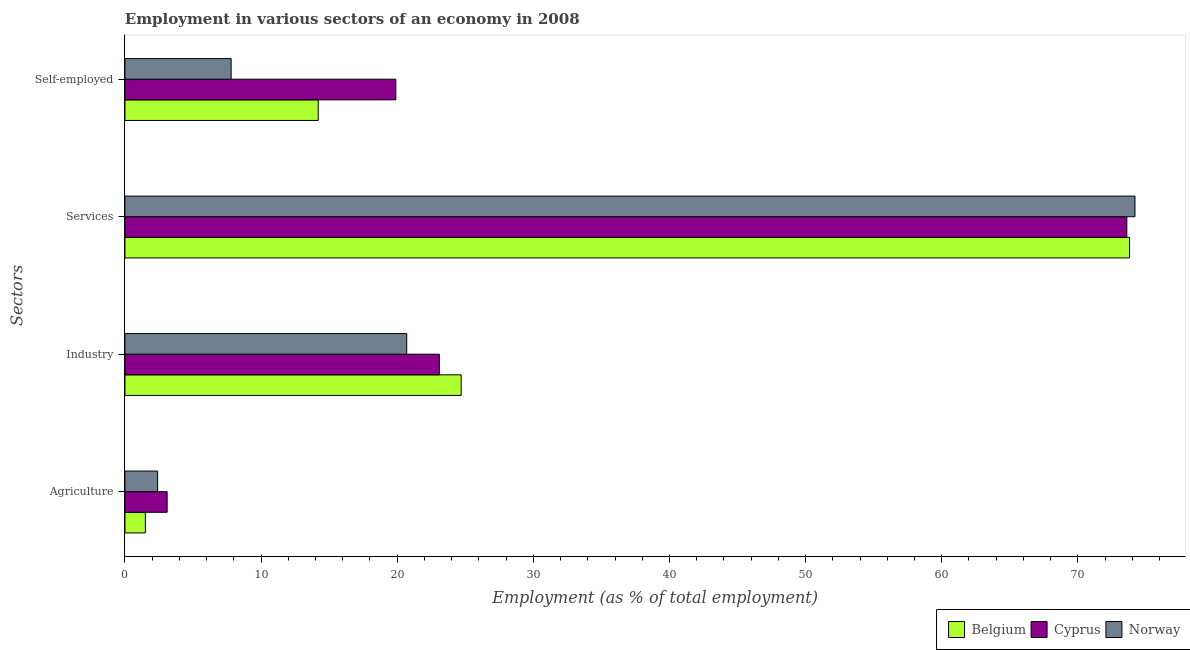How many different coloured bars are there?
Make the answer very short. 3. How many bars are there on the 1st tick from the top?
Give a very brief answer. 3. What is the label of the 3rd group of bars from the top?
Keep it short and to the point. Industry. What is the percentage of workers in agriculture in Norway?
Offer a terse response. 2.4. Across all countries, what is the maximum percentage of workers in services?
Offer a terse response. 74.2. Across all countries, what is the minimum percentage of workers in services?
Ensure brevity in your answer.  73.6. In which country was the percentage of self employed workers maximum?
Provide a succinct answer. Cyprus. In which country was the percentage of workers in services minimum?
Your response must be concise. Cyprus. What is the total percentage of workers in services in the graph?
Make the answer very short. 221.6. What is the difference between the percentage of workers in services in Belgium and that in Cyprus?
Ensure brevity in your answer.  0.2. What is the difference between the percentage of self employed workers in Cyprus and the percentage of workers in services in Belgium?
Offer a terse response. -53.9. What is the average percentage of workers in services per country?
Provide a succinct answer. 73.87. What is the difference between the percentage of self employed workers and percentage of workers in services in Belgium?
Your answer should be very brief. -59.6. What is the ratio of the percentage of workers in services in Cyprus to that in Norway?
Offer a terse response. 0.99. Is the percentage of self employed workers in Cyprus less than that in Belgium?
Your response must be concise. No. What is the difference between the highest and the second highest percentage of workers in industry?
Your response must be concise. 1.6. What is the difference between the highest and the lowest percentage of workers in agriculture?
Your response must be concise. 1.6. In how many countries, is the percentage of workers in industry greater than the average percentage of workers in industry taken over all countries?
Offer a very short reply. 2. Is it the case that in every country, the sum of the percentage of workers in industry and percentage of self employed workers is greater than the sum of percentage of workers in services and percentage of workers in agriculture?
Provide a short and direct response. No. What does the 2nd bar from the top in Agriculture represents?
Ensure brevity in your answer.  Cyprus. Is it the case that in every country, the sum of the percentage of workers in agriculture and percentage of workers in industry is greater than the percentage of workers in services?
Provide a short and direct response. No. Are all the bars in the graph horizontal?
Make the answer very short. Yes. How many countries are there in the graph?
Give a very brief answer. 3. What is the difference between two consecutive major ticks on the X-axis?
Give a very brief answer. 10. Does the graph contain any zero values?
Your response must be concise. No. Does the graph contain grids?
Your response must be concise. No. Where does the legend appear in the graph?
Your answer should be compact. Bottom right. How many legend labels are there?
Make the answer very short. 3. What is the title of the graph?
Offer a terse response. Employment in various sectors of an economy in 2008. What is the label or title of the X-axis?
Ensure brevity in your answer.  Employment (as % of total employment). What is the label or title of the Y-axis?
Make the answer very short. Sectors. What is the Employment (as % of total employment) in Cyprus in Agriculture?
Offer a terse response. 3.1. What is the Employment (as % of total employment) in Norway in Agriculture?
Offer a very short reply. 2.4. What is the Employment (as % of total employment) in Belgium in Industry?
Provide a succinct answer. 24.7. What is the Employment (as % of total employment) of Cyprus in Industry?
Your answer should be compact. 23.1. What is the Employment (as % of total employment) of Norway in Industry?
Offer a terse response. 20.7. What is the Employment (as % of total employment) of Belgium in Services?
Offer a very short reply. 73.8. What is the Employment (as % of total employment) of Cyprus in Services?
Offer a terse response. 73.6. What is the Employment (as % of total employment) in Norway in Services?
Provide a succinct answer. 74.2. What is the Employment (as % of total employment) in Belgium in Self-employed?
Ensure brevity in your answer.  14.2. What is the Employment (as % of total employment) of Cyprus in Self-employed?
Provide a succinct answer. 19.9. What is the Employment (as % of total employment) of Norway in Self-employed?
Make the answer very short. 7.8. Across all Sectors, what is the maximum Employment (as % of total employment) of Belgium?
Provide a short and direct response. 73.8. Across all Sectors, what is the maximum Employment (as % of total employment) in Cyprus?
Keep it short and to the point. 73.6. Across all Sectors, what is the maximum Employment (as % of total employment) in Norway?
Your answer should be compact. 74.2. Across all Sectors, what is the minimum Employment (as % of total employment) of Belgium?
Give a very brief answer. 1.5. Across all Sectors, what is the minimum Employment (as % of total employment) of Cyprus?
Provide a short and direct response. 3.1. Across all Sectors, what is the minimum Employment (as % of total employment) of Norway?
Give a very brief answer. 2.4. What is the total Employment (as % of total employment) in Belgium in the graph?
Your answer should be very brief. 114.2. What is the total Employment (as % of total employment) in Cyprus in the graph?
Give a very brief answer. 119.7. What is the total Employment (as % of total employment) of Norway in the graph?
Keep it short and to the point. 105.1. What is the difference between the Employment (as % of total employment) of Belgium in Agriculture and that in Industry?
Provide a short and direct response. -23.2. What is the difference between the Employment (as % of total employment) in Cyprus in Agriculture and that in Industry?
Provide a succinct answer. -20. What is the difference between the Employment (as % of total employment) in Norway in Agriculture and that in Industry?
Your answer should be compact. -18.3. What is the difference between the Employment (as % of total employment) of Belgium in Agriculture and that in Services?
Keep it short and to the point. -72.3. What is the difference between the Employment (as % of total employment) in Cyprus in Agriculture and that in Services?
Your response must be concise. -70.5. What is the difference between the Employment (as % of total employment) of Norway in Agriculture and that in Services?
Give a very brief answer. -71.8. What is the difference between the Employment (as % of total employment) of Belgium in Agriculture and that in Self-employed?
Your answer should be compact. -12.7. What is the difference between the Employment (as % of total employment) in Cyprus in Agriculture and that in Self-employed?
Your answer should be compact. -16.8. What is the difference between the Employment (as % of total employment) in Norway in Agriculture and that in Self-employed?
Your answer should be compact. -5.4. What is the difference between the Employment (as % of total employment) in Belgium in Industry and that in Services?
Your answer should be compact. -49.1. What is the difference between the Employment (as % of total employment) in Cyprus in Industry and that in Services?
Provide a short and direct response. -50.5. What is the difference between the Employment (as % of total employment) of Norway in Industry and that in Services?
Your answer should be compact. -53.5. What is the difference between the Employment (as % of total employment) in Belgium in Industry and that in Self-employed?
Your answer should be very brief. 10.5. What is the difference between the Employment (as % of total employment) of Belgium in Services and that in Self-employed?
Ensure brevity in your answer.  59.6. What is the difference between the Employment (as % of total employment) of Cyprus in Services and that in Self-employed?
Your answer should be compact. 53.7. What is the difference between the Employment (as % of total employment) in Norway in Services and that in Self-employed?
Keep it short and to the point. 66.4. What is the difference between the Employment (as % of total employment) in Belgium in Agriculture and the Employment (as % of total employment) in Cyprus in Industry?
Offer a terse response. -21.6. What is the difference between the Employment (as % of total employment) in Belgium in Agriculture and the Employment (as % of total employment) in Norway in Industry?
Make the answer very short. -19.2. What is the difference between the Employment (as % of total employment) of Cyprus in Agriculture and the Employment (as % of total employment) of Norway in Industry?
Your answer should be very brief. -17.6. What is the difference between the Employment (as % of total employment) in Belgium in Agriculture and the Employment (as % of total employment) in Cyprus in Services?
Give a very brief answer. -72.1. What is the difference between the Employment (as % of total employment) in Belgium in Agriculture and the Employment (as % of total employment) in Norway in Services?
Give a very brief answer. -72.7. What is the difference between the Employment (as % of total employment) of Cyprus in Agriculture and the Employment (as % of total employment) of Norway in Services?
Ensure brevity in your answer.  -71.1. What is the difference between the Employment (as % of total employment) of Belgium in Agriculture and the Employment (as % of total employment) of Cyprus in Self-employed?
Ensure brevity in your answer.  -18.4. What is the difference between the Employment (as % of total employment) in Belgium in Agriculture and the Employment (as % of total employment) in Norway in Self-employed?
Your response must be concise. -6.3. What is the difference between the Employment (as % of total employment) of Cyprus in Agriculture and the Employment (as % of total employment) of Norway in Self-employed?
Keep it short and to the point. -4.7. What is the difference between the Employment (as % of total employment) in Belgium in Industry and the Employment (as % of total employment) in Cyprus in Services?
Provide a short and direct response. -48.9. What is the difference between the Employment (as % of total employment) of Belgium in Industry and the Employment (as % of total employment) of Norway in Services?
Your answer should be compact. -49.5. What is the difference between the Employment (as % of total employment) of Cyprus in Industry and the Employment (as % of total employment) of Norway in Services?
Keep it short and to the point. -51.1. What is the difference between the Employment (as % of total employment) of Belgium in Industry and the Employment (as % of total employment) of Cyprus in Self-employed?
Give a very brief answer. 4.8. What is the difference between the Employment (as % of total employment) in Cyprus in Industry and the Employment (as % of total employment) in Norway in Self-employed?
Your answer should be very brief. 15.3. What is the difference between the Employment (as % of total employment) in Belgium in Services and the Employment (as % of total employment) in Cyprus in Self-employed?
Offer a terse response. 53.9. What is the difference between the Employment (as % of total employment) in Belgium in Services and the Employment (as % of total employment) in Norway in Self-employed?
Provide a short and direct response. 66. What is the difference between the Employment (as % of total employment) in Cyprus in Services and the Employment (as % of total employment) in Norway in Self-employed?
Offer a very short reply. 65.8. What is the average Employment (as % of total employment) of Belgium per Sectors?
Provide a succinct answer. 28.55. What is the average Employment (as % of total employment) of Cyprus per Sectors?
Provide a succinct answer. 29.93. What is the average Employment (as % of total employment) in Norway per Sectors?
Provide a succinct answer. 26.27. What is the difference between the Employment (as % of total employment) of Belgium and Employment (as % of total employment) of Norway in Agriculture?
Ensure brevity in your answer.  -0.9. What is the difference between the Employment (as % of total employment) in Cyprus and Employment (as % of total employment) in Norway in Agriculture?
Give a very brief answer. 0.7. What is the difference between the Employment (as % of total employment) of Belgium and Employment (as % of total employment) of Norway in Industry?
Offer a very short reply. 4. What is the difference between the Employment (as % of total employment) in Cyprus and Employment (as % of total employment) in Norway in Industry?
Give a very brief answer. 2.4. What is the difference between the Employment (as % of total employment) in Cyprus and Employment (as % of total employment) in Norway in Services?
Offer a terse response. -0.6. What is the ratio of the Employment (as % of total employment) in Belgium in Agriculture to that in Industry?
Your answer should be compact. 0.06. What is the ratio of the Employment (as % of total employment) in Cyprus in Agriculture to that in Industry?
Offer a very short reply. 0.13. What is the ratio of the Employment (as % of total employment) of Norway in Agriculture to that in Industry?
Make the answer very short. 0.12. What is the ratio of the Employment (as % of total employment) of Belgium in Agriculture to that in Services?
Give a very brief answer. 0.02. What is the ratio of the Employment (as % of total employment) of Cyprus in Agriculture to that in Services?
Offer a very short reply. 0.04. What is the ratio of the Employment (as % of total employment) in Norway in Agriculture to that in Services?
Keep it short and to the point. 0.03. What is the ratio of the Employment (as % of total employment) in Belgium in Agriculture to that in Self-employed?
Your answer should be compact. 0.11. What is the ratio of the Employment (as % of total employment) in Cyprus in Agriculture to that in Self-employed?
Make the answer very short. 0.16. What is the ratio of the Employment (as % of total employment) in Norway in Agriculture to that in Self-employed?
Make the answer very short. 0.31. What is the ratio of the Employment (as % of total employment) of Belgium in Industry to that in Services?
Provide a succinct answer. 0.33. What is the ratio of the Employment (as % of total employment) in Cyprus in Industry to that in Services?
Ensure brevity in your answer.  0.31. What is the ratio of the Employment (as % of total employment) in Norway in Industry to that in Services?
Give a very brief answer. 0.28. What is the ratio of the Employment (as % of total employment) of Belgium in Industry to that in Self-employed?
Offer a terse response. 1.74. What is the ratio of the Employment (as % of total employment) of Cyprus in Industry to that in Self-employed?
Give a very brief answer. 1.16. What is the ratio of the Employment (as % of total employment) of Norway in Industry to that in Self-employed?
Your answer should be very brief. 2.65. What is the ratio of the Employment (as % of total employment) of Belgium in Services to that in Self-employed?
Offer a terse response. 5.2. What is the ratio of the Employment (as % of total employment) of Cyprus in Services to that in Self-employed?
Ensure brevity in your answer.  3.7. What is the ratio of the Employment (as % of total employment) in Norway in Services to that in Self-employed?
Give a very brief answer. 9.51. What is the difference between the highest and the second highest Employment (as % of total employment) of Belgium?
Your answer should be compact. 49.1. What is the difference between the highest and the second highest Employment (as % of total employment) in Cyprus?
Keep it short and to the point. 50.5. What is the difference between the highest and the second highest Employment (as % of total employment) of Norway?
Ensure brevity in your answer.  53.5. What is the difference between the highest and the lowest Employment (as % of total employment) in Belgium?
Provide a succinct answer. 72.3. What is the difference between the highest and the lowest Employment (as % of total employment) of Cyprus?
Your answer should be compact. 70.5. What is the difference between the highest and the lowest Employment (as % of total employment) of Norway?
Ensure brevity in your answer.  71.8. 